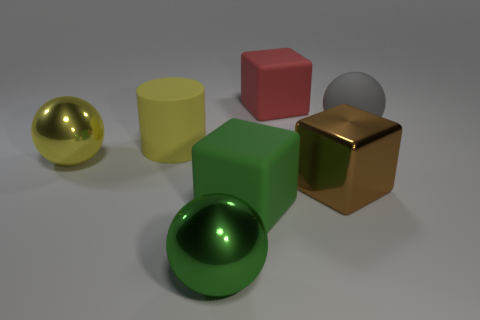Subtract all cyan balls. Subtract all blue cubes. How many balls are left? 3 Add 2 green matte objects. How many objects exist? 9 Subtract all cubes. How many objects are left? 4 Add 3 big yellow balls. How many big yellow balls are left? 4 Add 6 large blue metallic cylinders. How many large blue metallic cylinders exist? 6 Subtract 1 red blocks. How many objects are left? 6 Subtract all large rubber things. Subtract all tiny blocks. How many objects are left? 3 